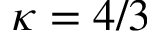Convert formula to latex. <formula><loc_0><loc_0><loc_500><loc_500>\kappa = 4 / 3</formula> 